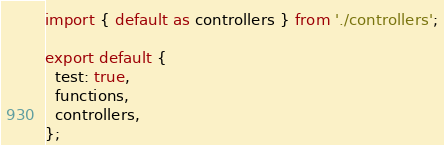Convert code to text. <code><loc_0><loc_0><loc_500><loc_500><_TypeScript_>import { default as controllers } from './controllers';

export default {
  test: true,
  functions,
  controllers,
};
</code> 